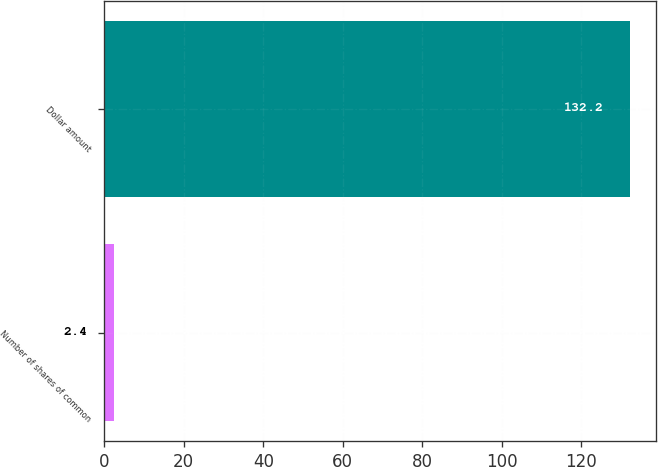Convert chart. <chart><loc_0><loc_0><loc_500><loc_500><bar_chart><fcel>Number of shares of common<fcel>Dollar amount<nl><fcel>2.4<fcel>132.2<nl></chart> 